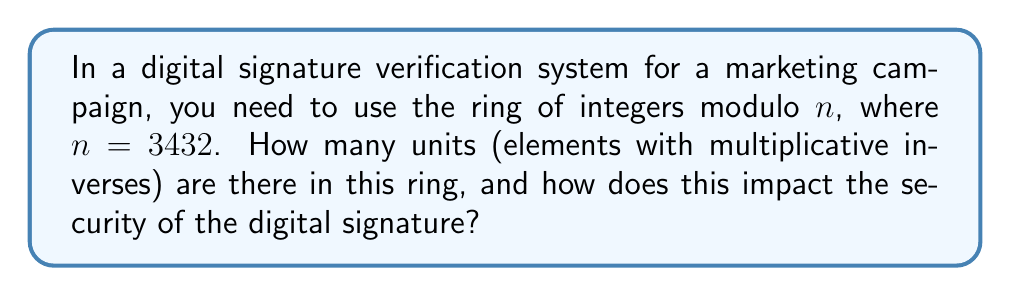Could you help me with this problem? To find the number of units in the ring of integers modulo $n$, we need to use the Euler's totient function $\phi(n)$. This function counts the number of integers between 1 and $n$ that are coprime to $n$. In a ring of integers modulo $n$, the units are precisely those elements that are coprime to $n$.

Steps to solve:

1) First, we need to factor $n = 3432$:
   $3432 = 2^3 \times 3 \times 11 \times 13$

2) For a prime $p$, $\phi(p) = p - 1$

3) For prime powers $p^k$, $\phi(p^k) = p^k - p^{k-1} = p^k(1 - \frac{1}{p})$

4) The Euler's totient function is multiplicative, meaning for coprime numbers $a$ and $b$, $\phi(ab) = \phi(a) \times \phi(b)$

5) Therefore:
   $$\begin{align}
   \phi(3432) &= \phi(2^3) \times \phi(3) \times \phi(11) \times \phi(13) \\
   &= (2^3 - 2^2) \times (3-1) \times (11-1) \times (13-1) \\
   &= 4 \times 2 \times 10 \times 12 \\
   &= 960
   \end{align}$$

The number of units in this ring is 960. This means there are 960 elements in the ring that have multiplicative inverses.

Impact on security: The security of many digital signature schemes relies on the difficulty of certain mathematical problems in the chosen ring. A larger number of units generally provides more options for cryptographic operations, potentially increasing security. However, the absolute size of the modulus (3432 in this case) is also crucial. For robust security in modern digital signatures, much larger moduli (typically 2048 bits or more) are used to resist factorization attacks.
Answer: There are 960 units in the ring of integers modulo 3432. 